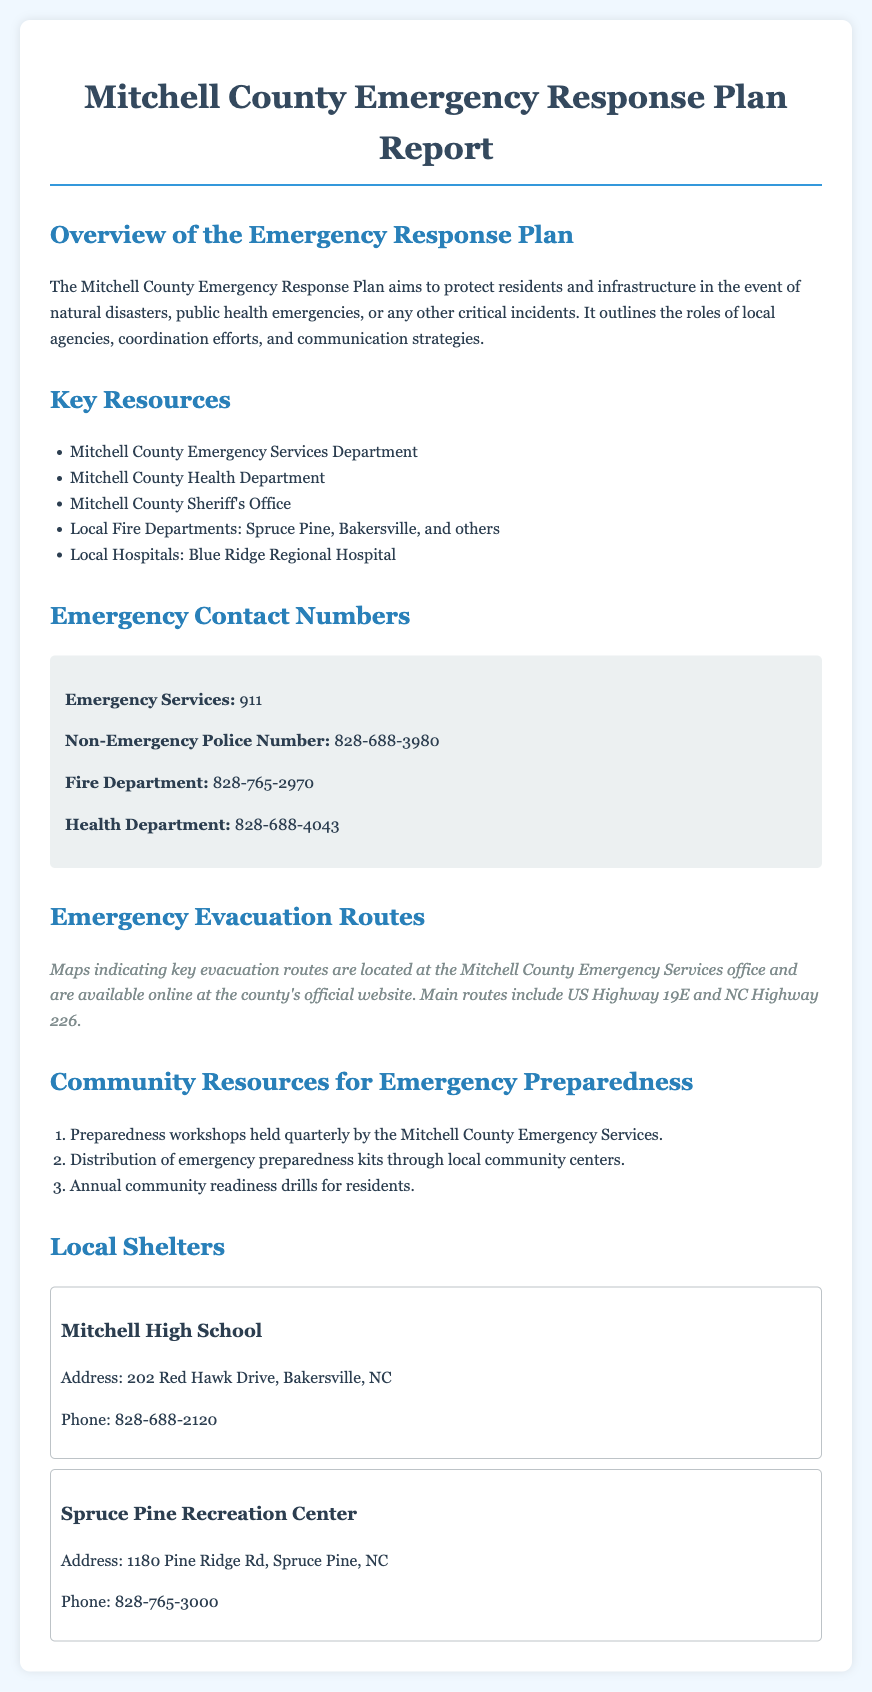what is the primary goal of the emergency response plan? The primary goal of the emergency response plan is to protect residents and infrastructure in the event of natural disasters, public health emergencies, or any other critical incidents.
Answer: protect residents and infrastructure which local hospital is mentioned in the report? The document lists Blue Ridge Regional Hospital as the local hospital in Mitchell County.
Answer: Blue Ridge Regional Hospital what is the emergency services phone number? The emergency services phone number is specified as 911 in the contact information section.
Answer: 911 how many local shelters are listed in the document? There are two local shelters mentioned in the report: Mitchell High School and Spruce Pine Recreation Center.
Answer: two what is the address of Spruce Pine Recreation Center? The address provided for Spruce Pine Recreation Center is 1180 Pine Ridge Rd, Spruce Pine, NC.
Answer: 1180 Pine Ridge Rd, Spruce Pine, NC which routes are identified as main evacuation routes? The document specifies US Highway 19E and NC Highway 226 as the main evacuation routes.
Answer: US Highway 19E and NC Highway 226 what type of workshops does the Mitchell County Emergency Services hold? The emergency services hold preparedness workshops quarterly for community members.
Answer: preparedness workshops how often are community readiness drills conducted? The report states that annual community readiness drills are conducted for residents.
Answer: annual who can be contacted at 828-688-4043? The contact number 828-688-4043 is for the Health Department as listed in the emergency contact numbers section.
Answer: Health Department 